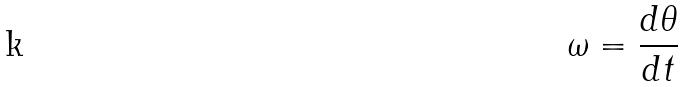<formula> <loc_0><loc_0><loc_500><loc_500>\omega = \frac { d \theta } { d t }</formula> 